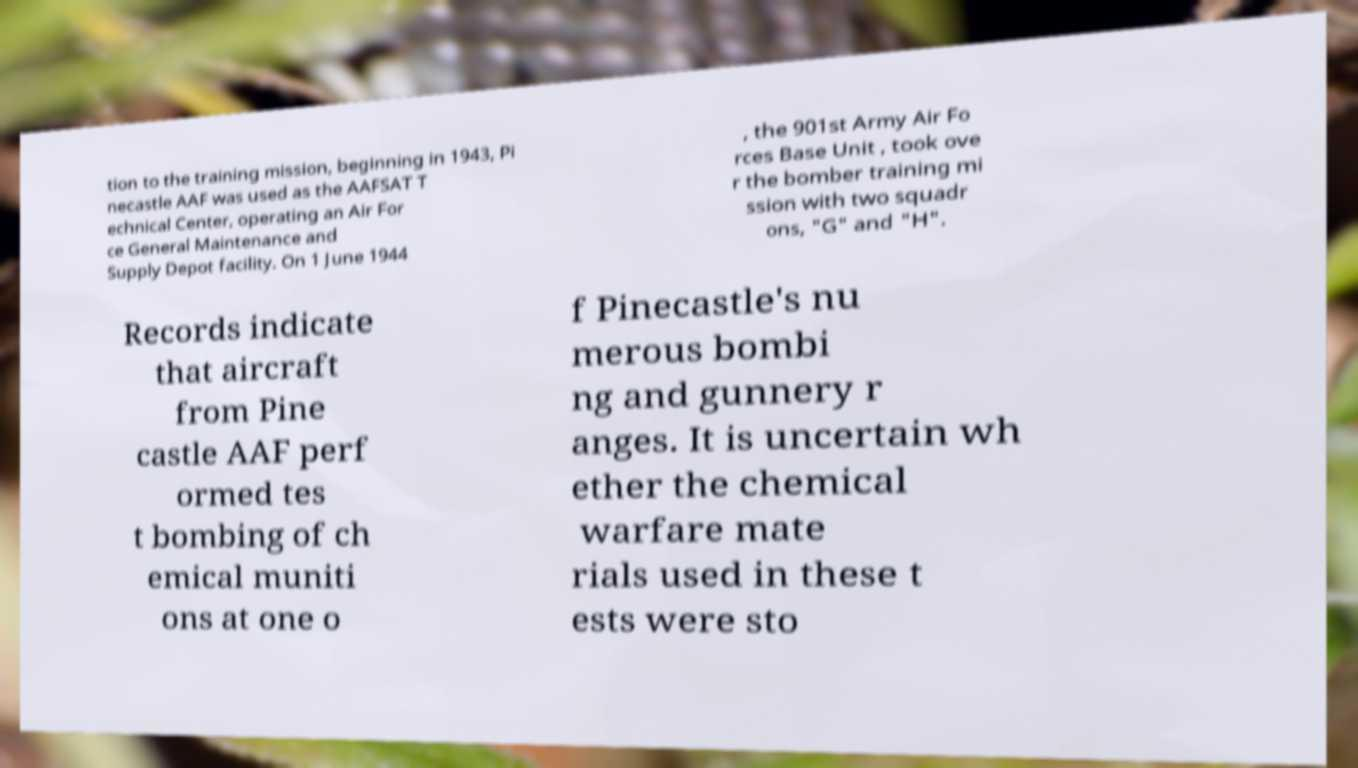There's text embedded in this image that I need extracted. Can you transcribe it verbatim? tion to the training mission, beginning in 1943, Pi necastle AAF was used as the AAFSAT T echnical Center, operating an Air For ce General Maintenance and Supply Depot facility. On 1 June 1944 , the 901st Army Air Fo rces Base Unit , took ove r the bomber training mi ssion with two squadr ons, "G" and "H". Records indicate that aircraft from Pine castle AAF perf ormed tes t bombing of ch emical muniti ons at one o f Pinecastle's nu merous bombi ng and gunnery r anges. It is uncertain wh ether the chemical warfare mate rials used in these t ests were sto 